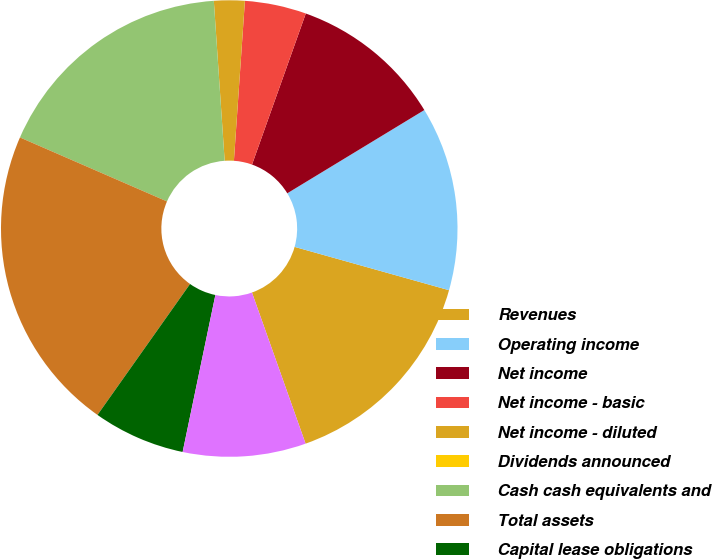Convert chart. <chart><loc_0><loc_0><loc_500><loc_500><pie_chart><fcel>Revenues<fcel>Operating income<fcel>Net income<fcel>Net income - basic<fcel>Net income - diluted<fcel>Dividends announced<fcel>Cash cash equivalents and<fcel>Total assets<fcel>Capital lease obligations<fcel>Other long-term liabilities<nl><fcel>15.22%<fcel>13.04%<fcel>10.87%<fcel>4.35%<fcel>2.17%<fcel>0.0%<fcel>17.39%<fcel>21.74%<fcel>6.52%<fcel>8.7%<nl></chart> 